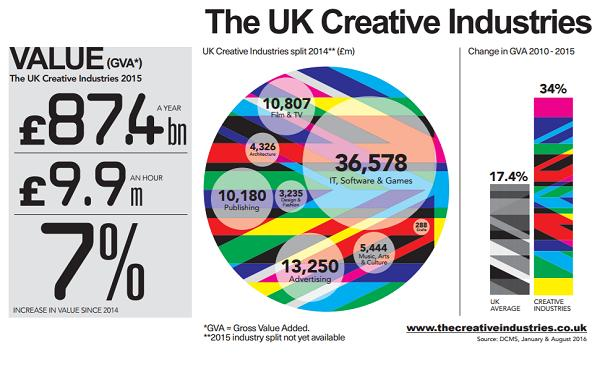Give some essential details in this illustration. In 2014, the creative industry with the highest GVA (gross value added) in the UK was the IT, software, and games industry. The total GVA (Gross Value Added) of Advertising and Publishing is 23,430. According to the data, the GVA percentage difference between the UK average and the creative industries during the period of 2010-2015 was 16.6%. 